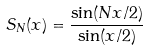<formula> <loc_0><loc_0><loc_500><loc_500>S _ { N } ( x ) = \frac { \sin ( N x / 2 ) } { \sin ( x / 2 ) }</formula> 